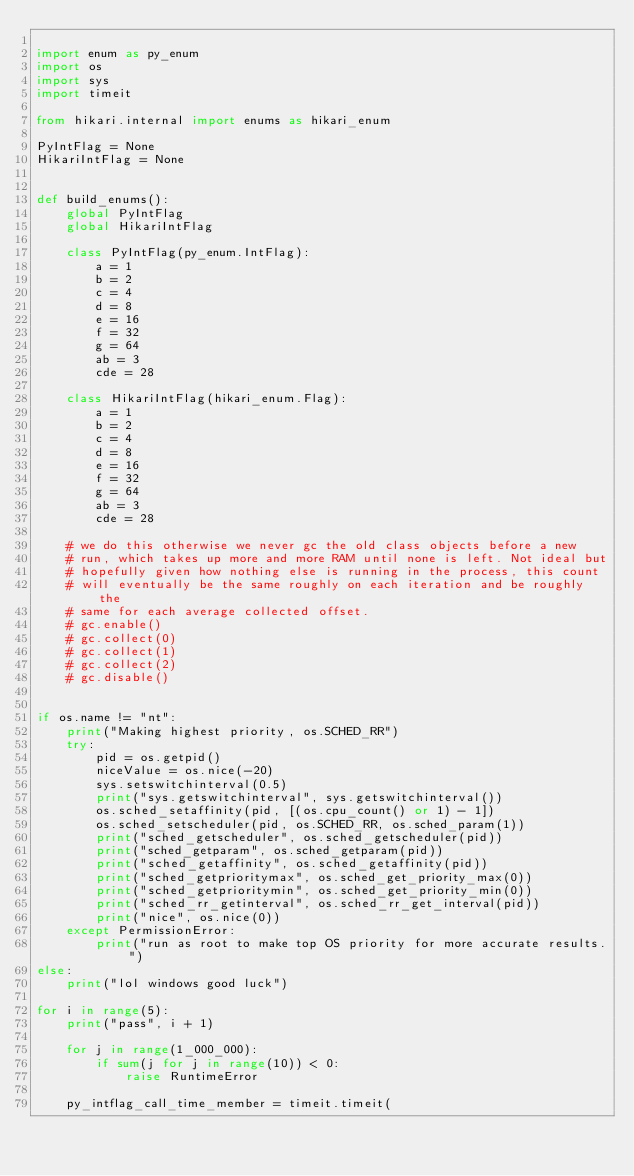<code> <loc_0><loc_0><loc_500><loc_500><_Python_>
import enum as py_enum
import os
import sys
import timeit

from hikari.internal import enums as hikari_enum

PyIntFlag = None
HikariIntFlag = None


def build_enums():
    global PyIntFlag
    global HikariIntFlag

    class PyIntFlag(py_enum.IntFlag):
        a = 1
        b = 2
        c = 4
        d = 8
        e = 16
        f = 32
        g = 64
        ab = 3
        cde = 28

    class HikariIntFlag(hikari_enum.Flag):
        a = 1
        b = 2
        c = 4
        d = 8
        e = 16
        f = 32
        g = 64
        ab = 3
        cde = 28

    # we do this otherwise we never gc the old class objects before a new
    # run, which takes up more and more RAM until none is left. Not ideal but
    # hopefully given how nothing else is running in the process, this count
    # will eventually be the same roughly on each iteration and be roughly the
    # same for each average collected offset.
    # gc.enable()
    # gc.collect(0)
    # gc.collect(1)
    # gc.collect(2)
    # gc.disable()


if os.name != "nt":
    print("Making highest priority, os.SCHED_RR")
    try:
        pid = os.getpid()
        niceValue = os.nice(-20)
        sys.setswitchinterval(0.5)
        print("sys.getswitchinterval", sys.getswitchinterval())
        os.sched_setaffinity(pid, [(os.cpu_count() or 1) - 1])
        os.sched_setscheduler(pid, os.SCHED_RR, os.sched_param(1))
        print("sched_getscheduler", os.sched_getscheduler(pid))
        print("sched_getparam", os.sched_getparam(pid))
        print("sched_getaffinity", os.sched_getaffinity(pid))
        print("sched_getprioritymax", os.sched_get_priority_max(0))
        print("sched_getprioritymin", os.sched_get_priority_min(0))
        print("sched_rr_getinterval", os.sched_rr_get_interval(pid))
        print("nice", os.nice(0))
    except PermissionError:
        print("run as root to make top OS priority for more accurate results.")
else:
    print("lol windows good luck")

for i in range(5):
    print("pass", i + 1)

    for j in range(1_000_000):
        if sum(j for j in range(10)) < 0:
            raise RuntimeError

    py_intflag_call_time_member = timeit.timeit(</code> 